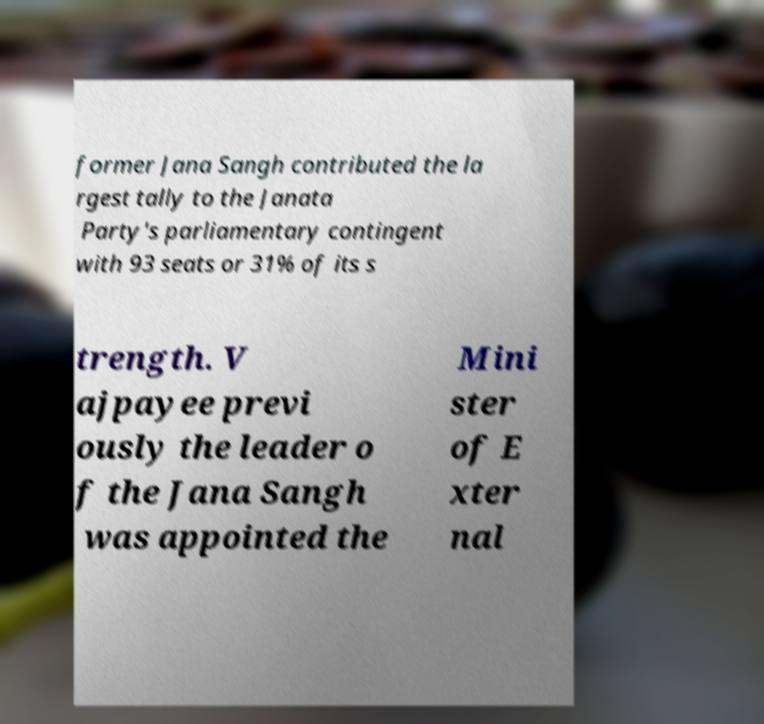Can you accurately transcribe the text from the provided image for me? former Jana Sangh contributed the la rgest tally to the Janata Party's parliamentary contingent with 93 seats or 31% of its s trength. V ajpayee previ ously the leader o f the Jana Sangh was appointed the Mini ster of E xter nal 